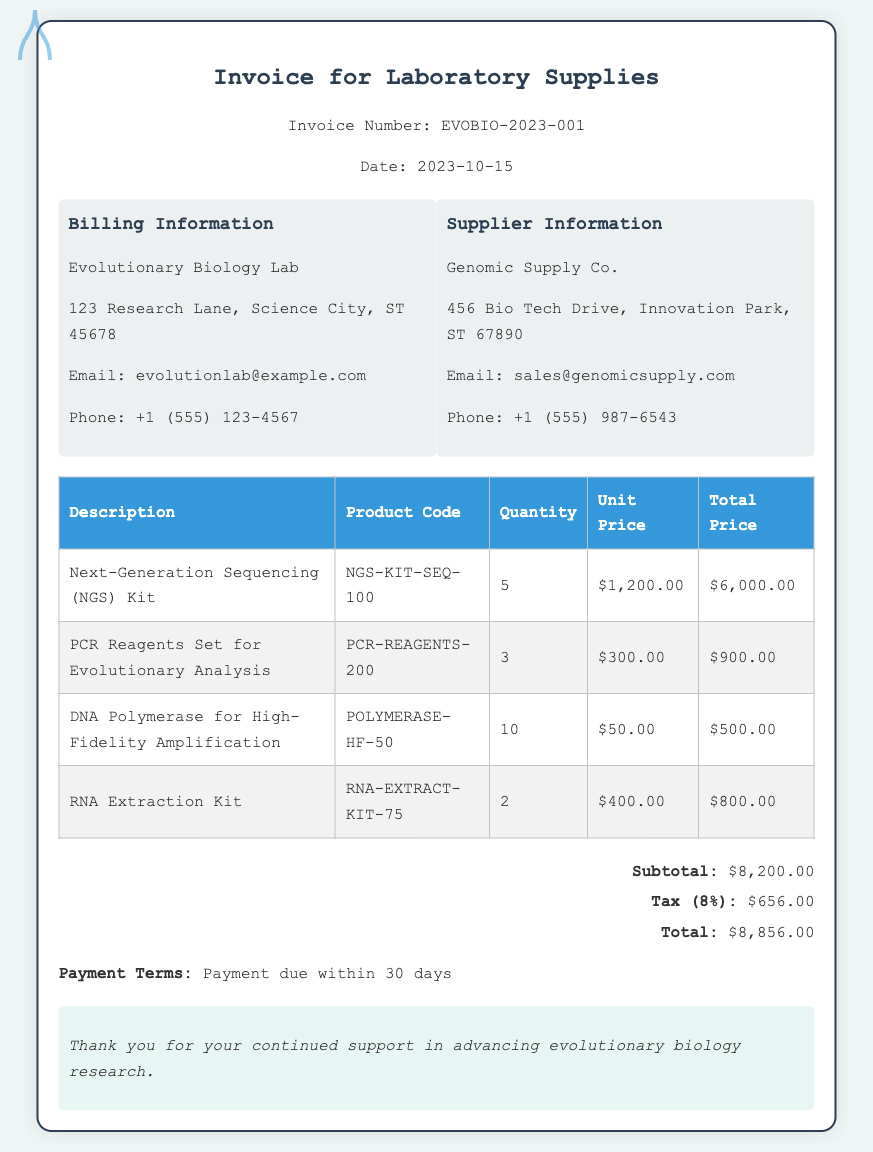What is the invoice number? The invoice number is stated clearly in the document for reference.
Answer: EVOBIO-2023-001 What is the date of the invoice? The date is also provided in the document along with the invoice number.
Answer: 2023-10-15 Who is the supplier? The supplier's name and contact information are listed in the document.
Answer: Genomic Supply Co What is the total price for the Next-Generation Sequencing Kit? The total price for each item is provided in the invoice table.
Answer: $6,000.00 How many DNA Polymerase units were ordered? The quantity for each product is specified in the document.
Answer: 10 What is the subtotal amount? The subtotal is computed before adding tax and is specified in the totals section.
Answer: $8,200.00 What are the payment terms? The document provides specific information about the payment terms for the invoice.
Answer: Payment due within 30 days What is the tax rate applied in the invoice? The tax rate is indicated alongside the subtotal to explain the calculation.
Answer: 8% How many PCR Reagents Sets were purchased? The quantity for this specific item can be found in the invoice table.
Answer: 3 What is the email address for the billing information? The document contains the email address for the billing information.
Answer: evolutionlab@example.com 